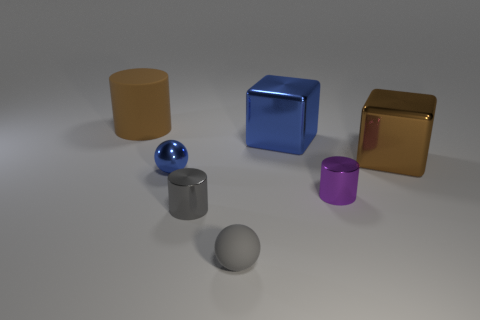How many purple things are the same size as the blue cube? 0 